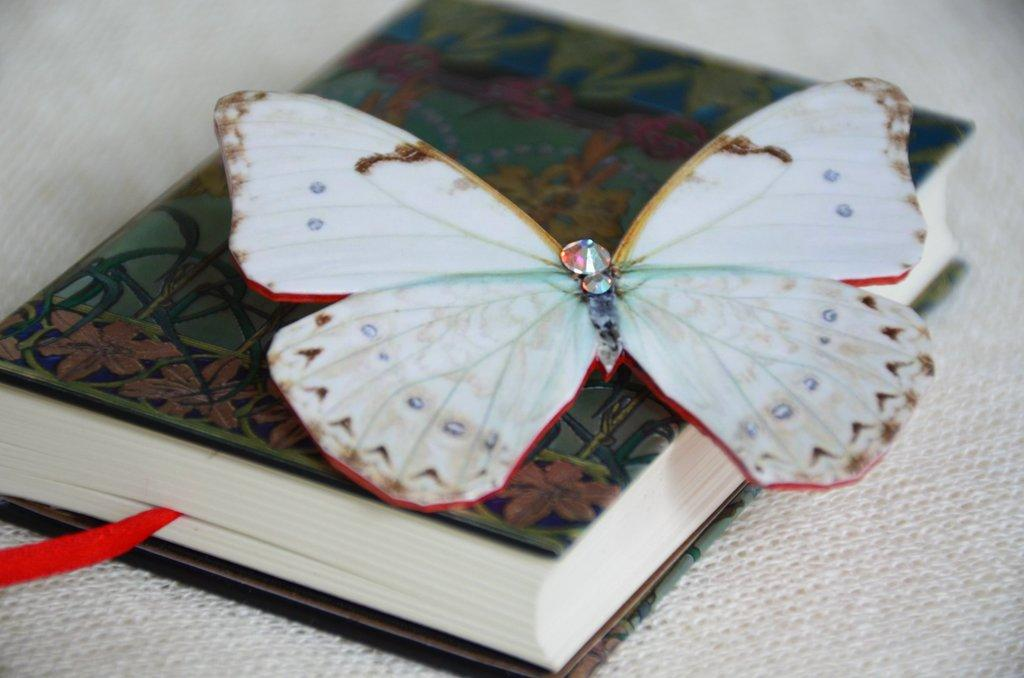What object can be seen in the image? There is a book in the image. What is unique about the book? The book has a sticker butterfly on it. What is the book placed on? The book is placed on a cloth. What is the weight of the book in the image? The weight of the book cannot be determined from the image alone, as it depends on various factors such as the size, thickness, and type of paper used. 